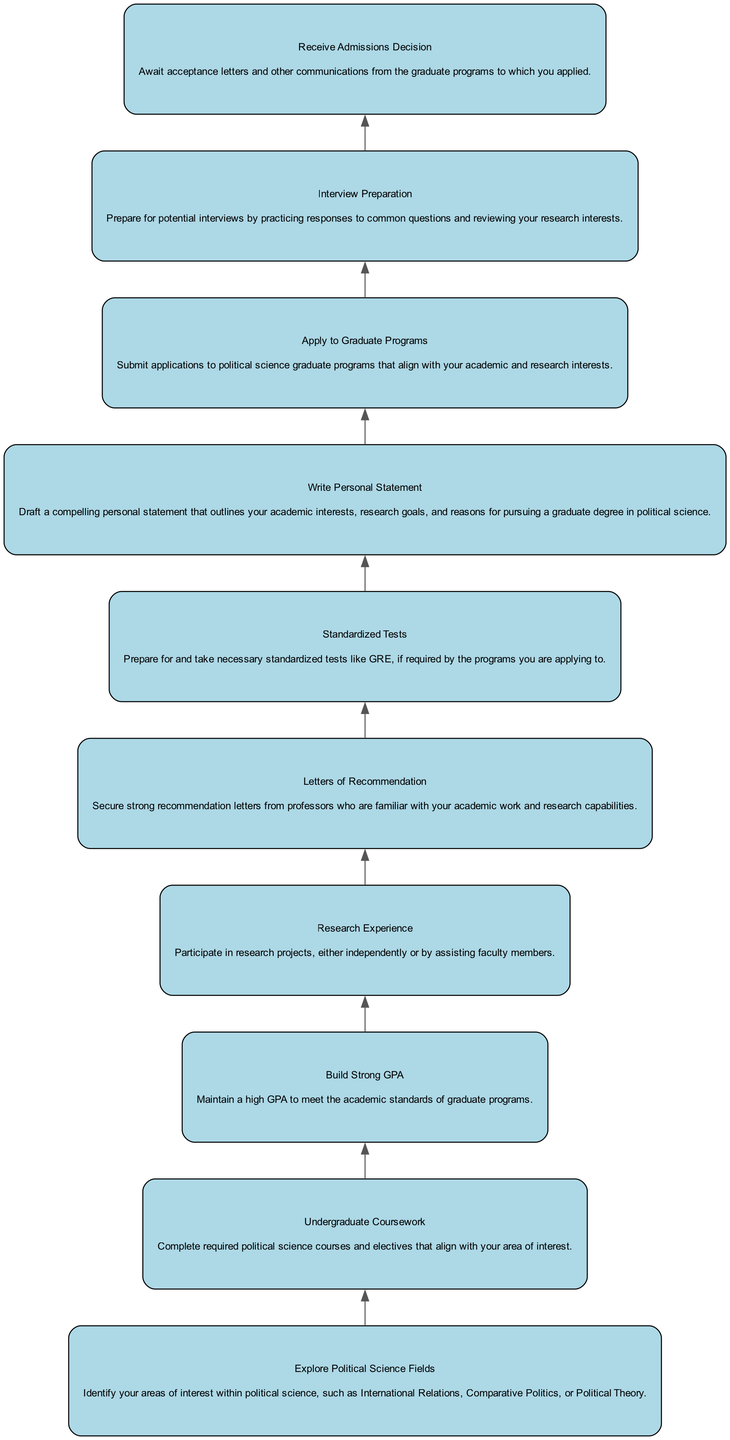What is the topmost node in the diagram? The topmost node in the flow chart is "Receive Admissions Decision." It is the final step in the path to graduate school, indicating that all previous steps must be completed before arriving at this point.
Answer: Receive Admissions Decision How many steps are there in the flowchart? The flowchart consists of 10 steps. Each step represents an important part of the process toward admission into graduate programs in political science.
Answer: 10 steps What is the first step in the path to graduate school? The first step is "Explore Political Science Fields." This initial step focuses on identifying specific interests within the discipline of political science.
Answer: Explore Political Science Fields What is required before "Apply to Graduate Programs"? Before "Apply to Graduate Programs," the steps "Letters of Recommendation," "Standardized Tests," and "Write Personal Statement" must be completed. These steps are essential for a strong application.
Answer: Letters of Recommendation, Standardized Tests, Write Personal Statement Which node describes maintaining academic standards? The node "Build Strong GPA" describes maintaining academic standards. This step emphasizes the importance of a high GPA in meeting the requirements for admission to graduate programs.
Answer: Build Strong GPA What is the relationship between "Research Experience" and "Letters of Recommendation"? "Research Experience" can lead to securing "Letters of Recommendation." Professors who are familiar with a student's research can provide stronger recommendations during the admissions process.
Answer: Research Experience leads to Letters of Recommendation What comes after preparing for interviews? After preparing for interviews, the next step is "Receive Admissions Decision." Preparing for interviews is crucial as it can directly impact the decision regarding admission.
Answer: Receive Admissions Decision What is the purpose of the "Personal Statement"? The purpose of the "Personal Statement" is to outline a student's academic interests, research goals, and motivations for pursuing a graduate degree in political science. It is a critical part of the application.
Answer: Outline academic interests, research goals, motivations Which two nodes are adjacent to "Apply to Graduate Programs"? The two nodes adjacent to "Apply to Graduate Programs" are "Write Personal Statement" above it and "Interview Preparation" below it. These steps are concurrently involved in the application process.
Answer: Write Personal Statement, Interview Preparation What node follows "Standardized Tests" in the diagram? The node that follows "Standardized Tests" is "Write Personal Statement." This indicates that after completing the tests, the next action is to draft a personal statement for the application.
Answer: Write Personal Statement 